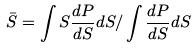Convert formula to latex. <formula><loc_0><loc_0><loc_500><loc_500>\bar { S } = \int S \frac { d P } { d S } d S / \int \frac { d P } { d S } d S</formula> 